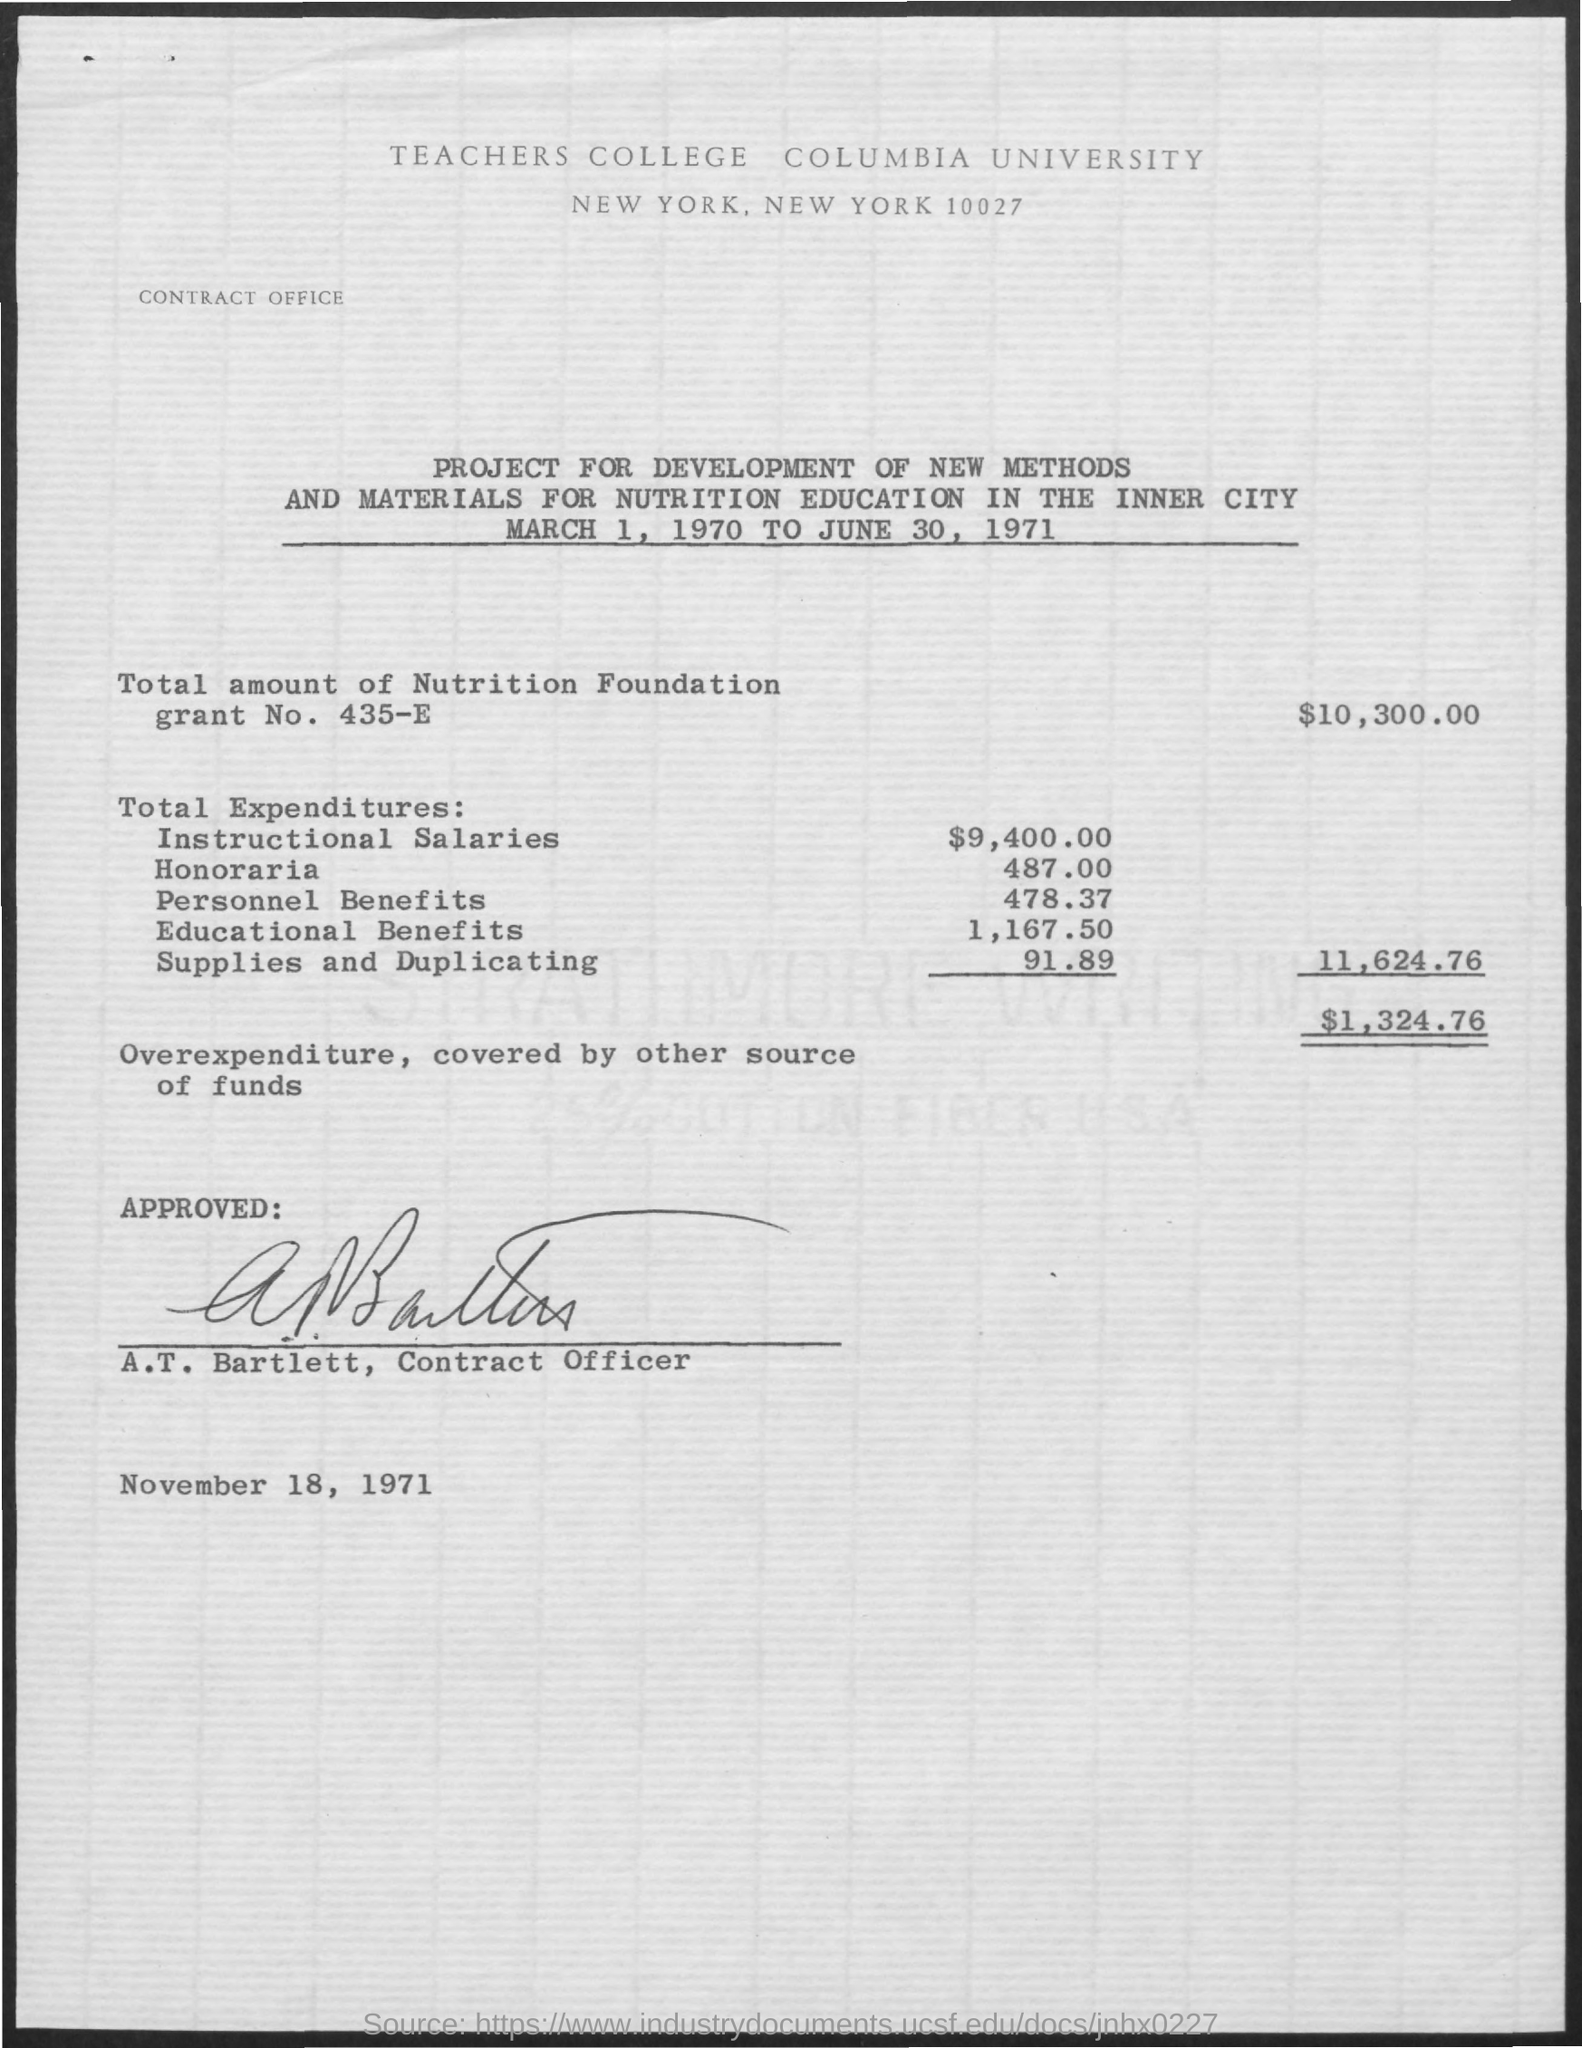Point out several critical features in this image. The total expenditure on personal benefits was $478.37. Columbia University is located in New York City. The name of the contract officer is A.T. Bartlett. On November 18, 1971, the date of approval was. The project for the development of new methods and materials was initiated on March 1, 1970 and completed on June 30, 1971. 